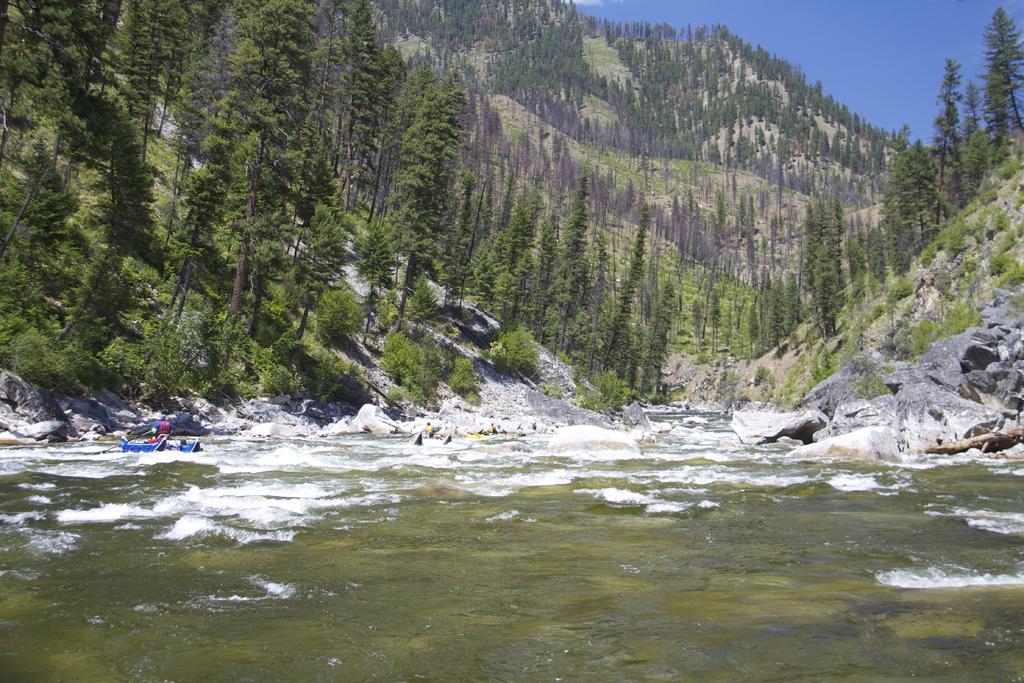In one or two sentences, can you explain what this image depicts? In this image there is water and we can see boats on the water. There are rocks and we can see people in the boats. In the background there are trees, hills and sky. 